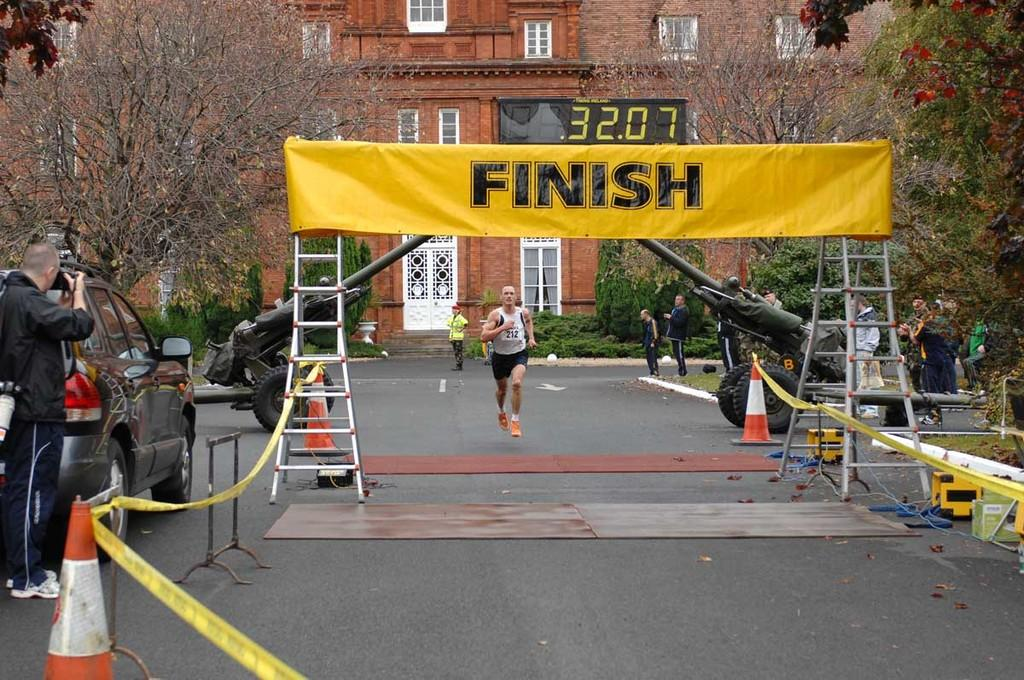<image>
Relay a brief, clear account of the picture shown. Man is running on the road headed to the finish line 